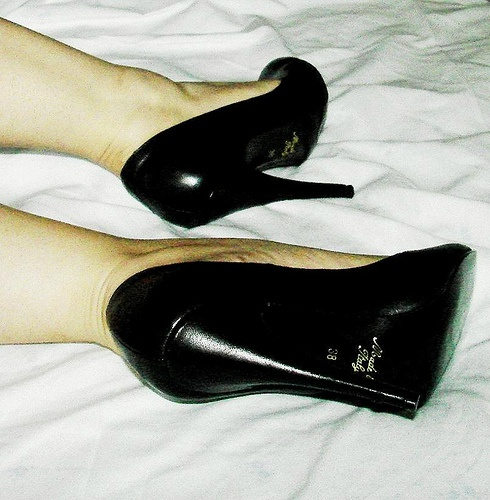Describe the objects in this image and their specific colors. I can see bed in lightgray and darkgray tones and people in lightgray, black, beige, and tan tones in this image. 